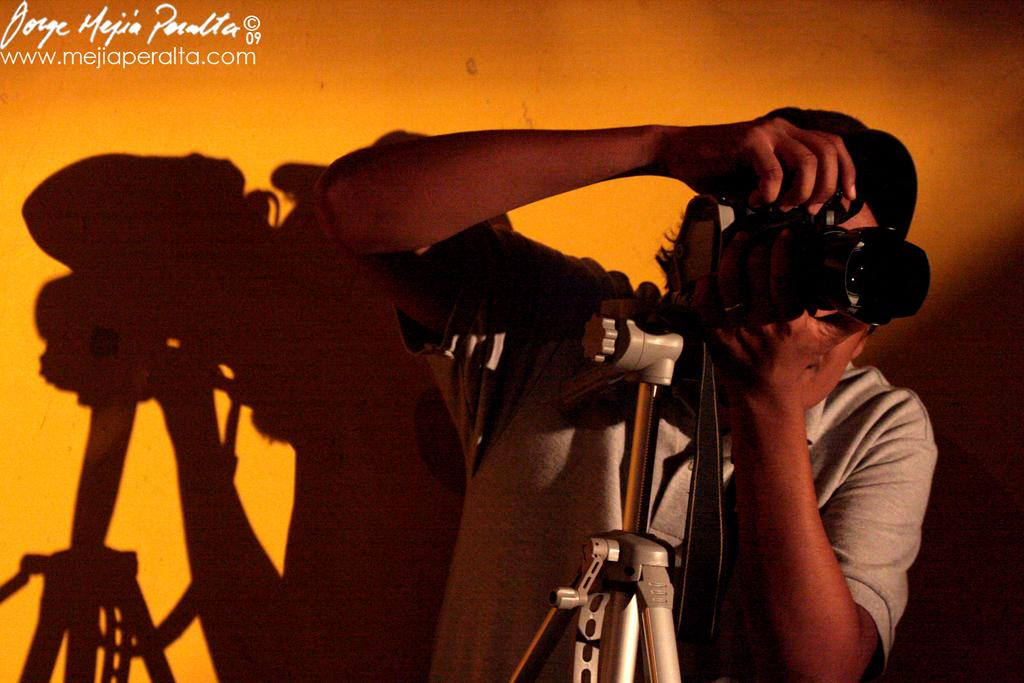Who is present in the image? There is a person in the image. What is the person holding in their hands? The person is holding a camera in their hands. What other equipment can be seen in the image? There is a tripod in the image. What type of setting is visible in the image? There are walls visible in the image, suggesting an indoor location. What type of stitch is the person using to sew a bike in the image? There is no stitch or bike present in the image; it features a person holding a camera and a tripod. 